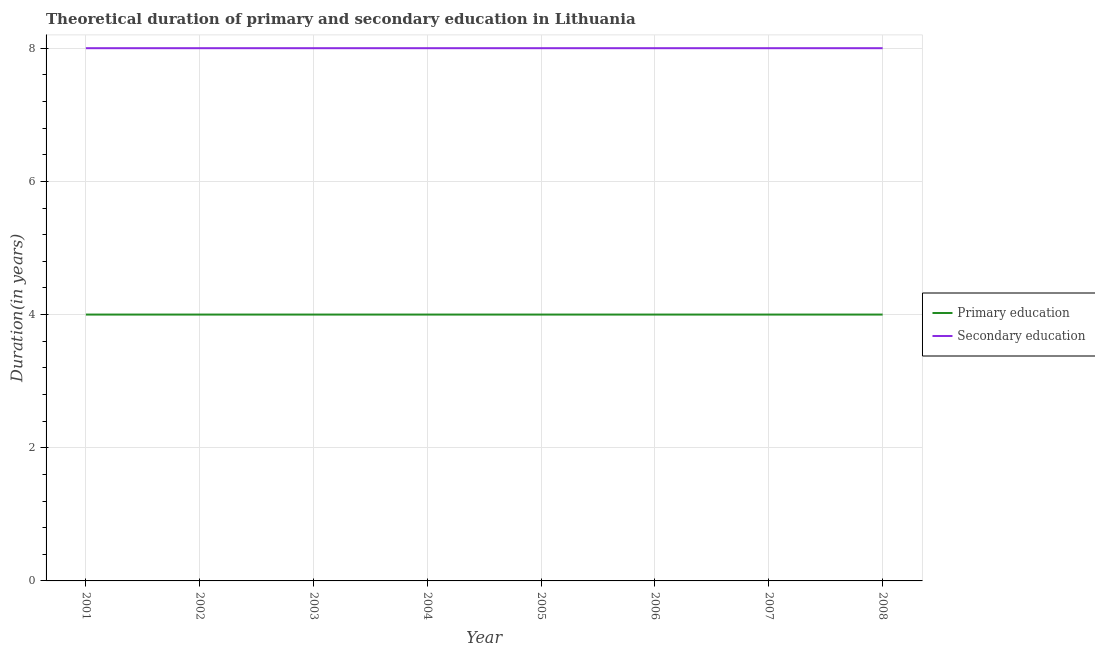How many different coloured lines are there?
Give a very brief answer. 2. Is the number of lines equal to the number of legend labels?
Keep it short and to the point. Yes. What is the duration of primary education in 2002?
Keep it short and to the point. 4. Across all years, what is the maximum duration of primary education?
Provide a short and direct response. 4. Across all years, what is the minimum duration of primary education?
Ensure brevity in your answer.  4. In which year was the duration of primary education maximum?
Keep it short and to the point. 2001. What is the total duration of secondary education in the graph?
Offer a terse response. 64. What is the difference between the duration of primary education in 2007 and that in 2008?
Provide a short and direct response. 0. What is the difference between the duration of primary education in 2006 and the duration of secondary education in 2001?
Keep it short and to the point. -4. In the year 2007, what is the difference between the duration of secondary education and duration of primary education?
Give a very brief answer. 4. Is the duration of primary education in 2001 less than that in 2002?
Offer a very short reply. No. In how many years, is the duration of primary education greater than the average duration of primary education taken over all years?
Offer a terse response. 0. Is the sum of the duration of secondary education in 2001 and 2004 greater than the maximum duration of primary education across all years?
Your answer should be compact. Yes. Is the duration of primary education strictly greater than the duration of secondary education over the years?
Offer a terse response. No. Is the duration of secondary education strictly less than the duration of primary education over the years?
Your answer should be very brief. No. How many lines are there?
Ensure brevity in your answer.  2. How many years are there in the graph?
Provide a succinct answer. 8. Does the graph contain any zero values?
Ensure brevity in your answer.  No. Does the graph contain grids?
Make the answer very short. Yes. What is the title of the graph?
Your response must be concise. Theoretical duration of primary and secondary education in Lithuania. Does "Attending school" appear as one of the legend labels in the graph?
Offer a terse response. No. What is the label or title of the Y-axis?
Provide a succinct answer. Duration(in years). What is the Duration(in years) of Secondary education in 2004?
Make the answer very short. 8. What is the Duration(in years) of Secondary education in 2006?
Offer a very short reply. 8. What is the Duration(in years) in Secondary education in 2007?
Provide a succinct answer. 8. What is the Duration(in years) of Primary education in 2008?
Provide a short and direct response. 4. Across all years, what is the maximum Duration(in years) in Primary education?
Your response must be concise. 4. Across all years, what is the minimum Duration(in years) in Secondary education?
Your answer should be compact. 8. What is the total Duration(in years) in Primary education in the graph?
Ensure brevity in your answer.  32. What is the difference between the Duration(in years) in Primary education in 2001 and that in 2002?
Provide a short and direct response. 0. What is the difference between the Duration(in years) of Secondary education in 2001 and that in 2002?
Offer a terse response. 0. What is the difference between the Duration(in years) in Primary education in 2001 and that in 2003?
Your answer should be compact. 0. What is the difference between the Duration(in years) in Primary education in 2001 and that in 2005?
Your answer should be compact. 0. What is the difference between the Duration(in years) of Primary education in 2001 and that in 2007?
Your response must be concise. 0. What is the difference between the Duration(in years) in Secondary education in 2001 and that in 2007?
Your answer should be compact. 0. What is the difference between the Duration(in years) of Primary education in 2001 and that in 2008?
Keep it short and to the point. 0. What is the difference between the Duration(in years) of Secondary education in 2001 and that in 2008?
Offer a terse response. 0. What is the difference between the Duration(in years) in Primary education in 2002 and that in 2004?
Provide a short and direct response. 0. What is the difference between the Duration(in years) in Primary education in 2002 and that in 2006?
Offer a very short reply. 0. What is the difference between the Duration(in years) in Primary education in 2002 and that in 2007?
Make the answer very short. 0. What is the difference between the Duration(in years) in Primary education in 2002 and that in 2008?
Ensure brevity in your answer.  0. What is the difference between the Duration(in years) in Primary education in 2003 and that in 2004?
Provide a short and direct response. 0. What is the difference between the Duration(in years) of Secondary education in 2003 and that in 2004?
Your answer should be very brief. 0. What is the difference between the Duration(in years) of Primary education in 2003 and that in 2005?
Your response must be concise. 0. What is the difference between the Duration(in years) in Primary education in 2003 and that in 2007?
Give a very brief answer. 0. What is the difference between the Duration(in years) of Primary education in 2004 and that in 2005?
Offer a terse response. 0. What is the difference between the Duration(in years) in Secondary education in 2004 and that in 2007?
Your answer should be very brief. 0. What is the difference between the Duration(in years) in Primary education in 2005 and that in 2006?
Your answer should be very brief. 0. What is the difference between the Duration(in years) in Secondary education in 2005 and that in 2008?
Provide a succinct answer. 0. What is the difference between the Duration(in years) of Secondary education in 2006 and that in 2007?
Give a very brief answer. 0. What is the difference between the Duration(in years) in Primary education in 2007 and that in 2008?
Offer a terse response. 0. What is the difference between the Duration(in years) in Primary education in 2001 and the Duration(in years) in Secondary education in 2002?
Ensure brevity in your answer.  -4. What is the difference between the Duration(in years) in Primary education in 2001 and the Duration(in years) in Secondary education in 2003?
Provide a succinct answer. -4. What is the difference between the Duration(in years) of Primary education in 2001 and the Duration(in years) of Secondary education in 2006?
Your answer should be compact. -4. What is the difference between the Duration(in years) of Primary education in 2001 and the Duration(in years) of Secondary education in 2007?
Make the answer very short. -4. What is the difference between the Duration(in years) of Primary education in 2002 and the Duration(in years) of Secondary education in 2003?
Keep it short and to the point. -4. What is the difference between the Duration(in years) of Primary education in 2002 and the Duration(in years) of Secondary education in 2007?
Make the answer very short. -4. What is the difference between the Duration(in years) of Primary education in 2002 and the Duration(in years) of Secondary education in 2008?
Your response must be concise. -4. What is the difference between the Duration(in years) of Primary education in 2003 and the Duration(in years) of Secondary education in 2004?
Provide a short and direct response. -4. What is the difference between the Duration(in years) of Primary education in 2003 and the Duration(in years) of Secondary education in 2008?
Keep it short and to the point. -4. What is the difference between the Duration(in years) of Primary education in 2004 and the Duration(in years) of Secondary education in 2005?
Give a very brief answer. -4. What is the difference between the Duration(in years) of Primary education in 2004 and the Duration(in years) of Secondary education in 2008?
Provide a short and direct response. -4. What is the difference between the Duration(in years) of Primary education in 2005 and the Duration(in years) of Secondary education in 2007?
Offer a very short reply. -4. What is the difference between the Duration(in years) in Primary education in 2005 and the Duration(in years) in Secondary education in 2008?
Make the answer very short. -4. What is the average Duration(in years) in Secondary education per year?
Your response must be concise. 8. In the year 2001, what is the difference between the Duration(in years) of Primary education and Duration(in years) of Secondary education?
Your response must be concise. -4. In the year 2002, what is the difference between the Duration(in years) in Primary education and Duration(in years) in Secondary education?
Provide a short and direct response. -4. In the year 2004, what is the difference between the Duration(in years) of Primary education and Duration(in years) of Secondary education?
Offer a terse response. -4. What is the ratio of the Duration(in years) in Primary education in 2001 to that in 2002?
Offer a terse response. 1. What is the ratio of the Duration(in years) in Secondary education in 2001 to that in 2002?
Your response must be concise. 1. What is the ratio of the Duration(in years) of Primary education in 2001 to that in 2003?
Make the answer very short. 1. What is the ratio of the Duration(in years) in Secondary education in 2001 to that in 2003?
Offer a terse response. 1. What is the ratio of the Duration(in years) in Primary education in 2001 to that in 2004?
Provide a short and direct response. 1. What is the ratio of the Duration(in years) in Secondary education in 2001 to that in 2004?
Offer a terse response. 1. What is the ratio of the Duration(in years) of Secondary education in 2001 to that in 2005?
Offer a very short reply. 1. What is the ratio of the Duration(in years) in Primary education in 2001 to that in 2008?
Ensure brevity in your answer.  1. What is the ratio of the Duration(in years) of Secondary education in 2001 to that in 2008?
Your answer should be compact. 1. What is the ratio of the Duration(in years) in Primary education in 2002 to that in 2003?
Provide a short and direct response. 1. What is the ratio of the Duration(in years) of Secondary education in 2002 to that in 2003?
Your answer should be compact. 1. What is the ratio of the Duration(in years) of Secondary education in 2002 to that in 2004?
Provide a short and direct response. 1. What is the ratio of the Duration(in years) of Primary education in 2002 to that in 2005?
Make the answer very short. 1. What is the ratio of the Duration(in years) of Secondary education in 2002 to that in 2005?
Offer a terse response. 1. What is the ratio of the Duration(in years) in Primary education in 2002 to that in 2006?
Ensure brevity in your answer.  1. What is the ratio of the Duration(in years) of Secondary education in 2002 to that in 2006?
Offer a terse response. 1. What is the ratio of the Duration(in years) of Secondary education in 2003 to that in 2004?
Your answer should be compact. 1. What is the ratio of the Duration(in years) of Secondary education in 2003 to that in 2008?
Ensure brevity in your answer.  1. What is the ratio of the Duration(in years) in Primary education in 2004 to that in 2005?
Give a very brief answer. 1. What is the ratio of the Duration(in years) of Primary education in 2004 to that in 2007?
Ensure brevity in your answer.  1. What is the ratio of the Duration(in years) in Secondary education in 2004 to that in 2008?
Provide a short and direct response. 1. What is the ratio of the Duration(in years) in Primary education in 2005 to that in 2008?
Give a very brief answer. 1. What is the ratio of the Duration(in years) of Primary education in 2006 to that in 2007?
Make the answer very short. 1. What is the ratio of the Duration(in years) in Secondary education in 2007 to that in 2008?
Your answer should be very brief. 1. What is the difference between the highest and the lowest Duration(in years) in Primary education?
Ensure brevity in your answer.  0. What is the difference between the highest and the lowest Duration(in years) in Secondary education?
Make the answer very short. 0. 